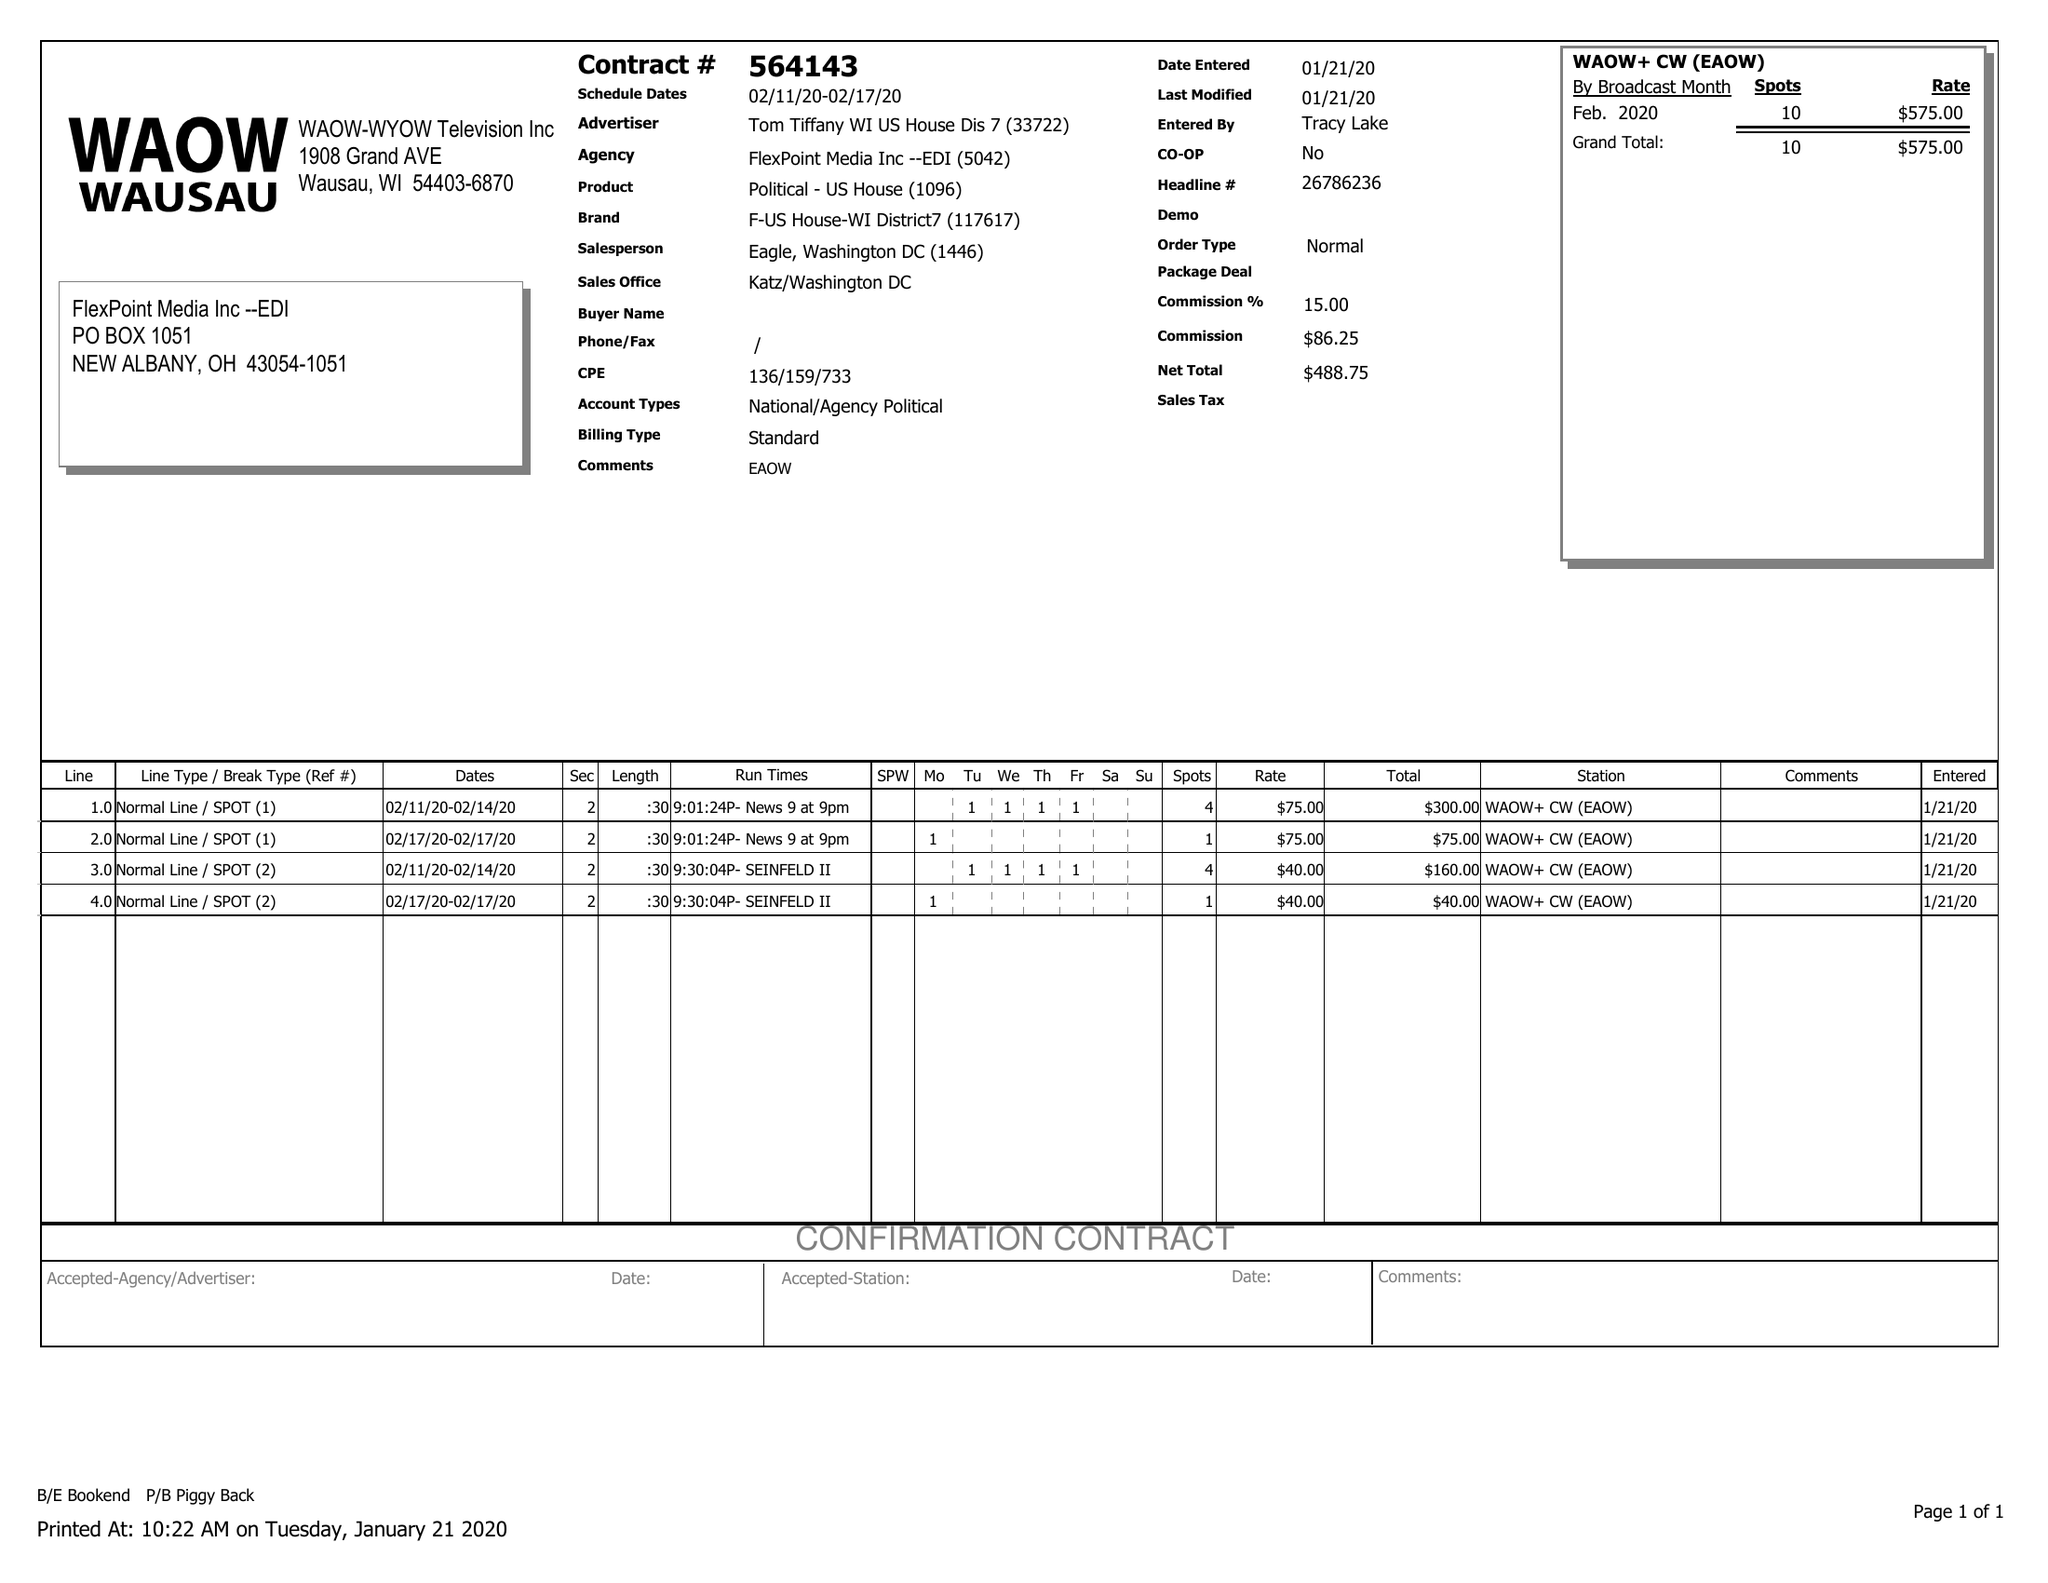What is the value for the gross_amount?
Answer the question using a single word or phrase. 575.00 